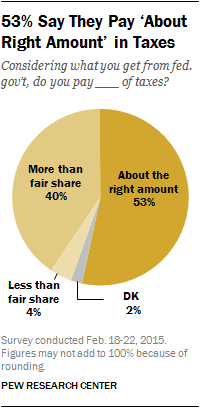Identify some key points in this picture. What is the median of all the segments, which are 22? The yellow segment has a percentage value of 53%. 